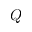<formula> <loc_0><loc_0><loc_500><loc_500>Q</formula> 